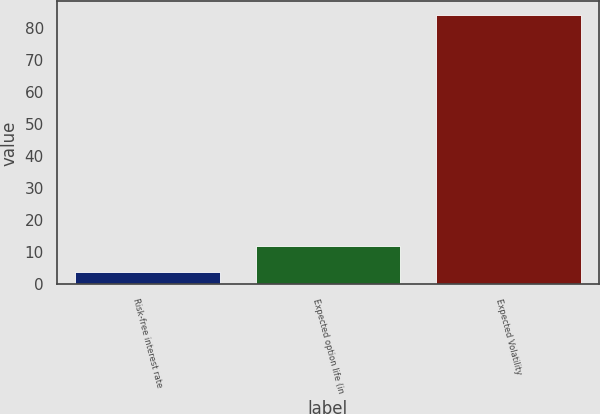<chart> <loc_0><loc_0><loc_500><loc_500><bar_chart><fcel>Risk-free interest rate<fcel>Expected option life (in<fcel>Expected Volatility<nl><fcel>3.87<fcel>11.88<fcel>84<nl></chart> 